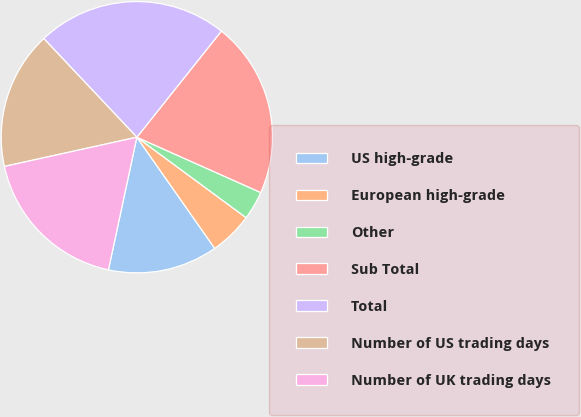Convert chart. <chart><loc_0><loc_0><loc_500><loc_500><pie_chart><fcel>US high-grade<fcel>European high-grade<fcel>Other<fcel>Sub Total<fcel>Total<fcel>Number of US trading days<fcel>Number of UK trading days<nl><fcel>13.09%<fcel>5.17%<fcel>3.42%<fcel>20.98%<fcel>22.74%<fcel>16.42%<fcel>18.18%<nl></chart> 